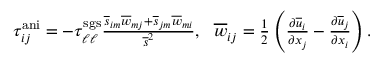<formula> <loc_0><loc_0><loc_500><loc_500>\begin{array} { r } { \tau _ { i j } ^ { a n i } = - \tau _ { \ell \ell } ^ { s g s } \frac { \overline { s } _ { i m } \overline { w } _ { m j } + \overline { s } _ { j m } \overline { w } _ { m i } } { \overline { s } ^ { 2 } } , \quad o v e r l i n e { w } _ { i j } = \frac { 1 } { 2 } \left ( \frac { \partial \overline { u } _ { i } } { \partial x _ { j } } - \frac { \partial \overline { u } _ { j } } { \partial x _ { i } } \right ) . } \end{array}</formula> 